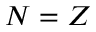Convert formula to latex. <formula><loc_0><loc_0><loc_500><loc_500>N = Z</formula> 